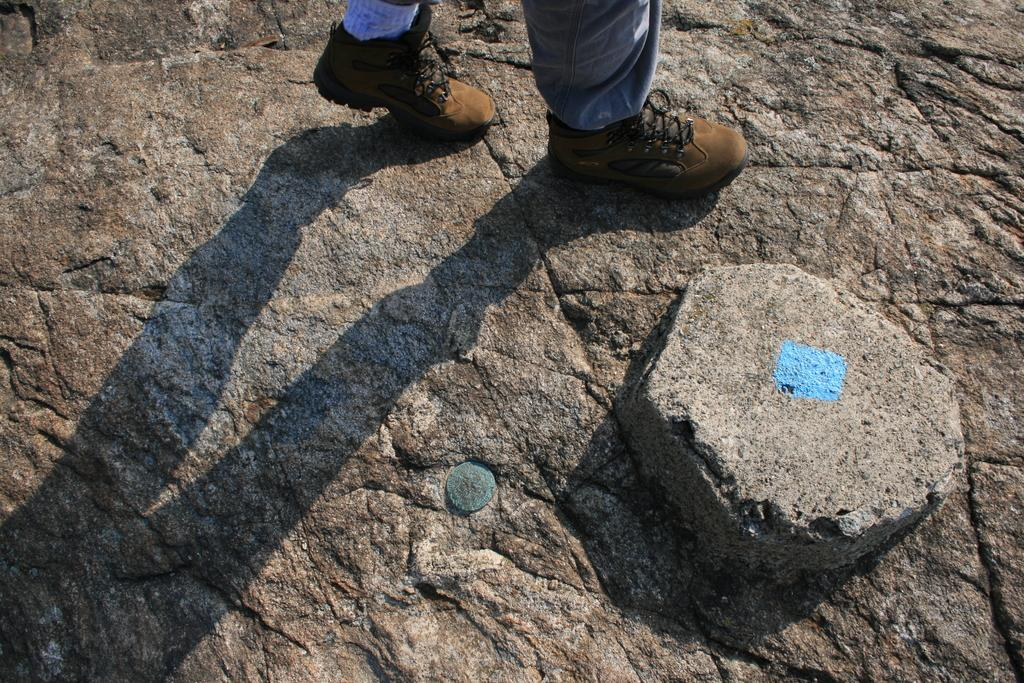What is the main object in the foreground of the image? There is a stone in the foreground of the image. Can you describe the person in the image? The image shows the legs of a person sitting on a rock. What type of vein is visible on the person's leg in the image? There is no visible vein on the person's leg in the image. Can you tell me what card game the person is playing in the image? There is no indication of a card game or any cards in the image. 